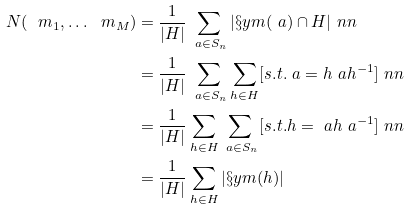Convert formula to latex. <formula><loc_0><loc_0><loc_500><loc_500>N ( \ m _ { 1 } , \dots \ m _ { M } ) & = \frac { 1 } { | H | } \sum _ { \ a \in S _ { n } } | \S y m ( \ a ) \cap H | \ n n \\ & = \frac { 1 } { | H | } \sum _ { \ a \in S _ { n } } \sum _ { h \in H } [ s . t . \ a = h \ a h ^ { - 1 } ] \ n n \\ & = \frac { 1 } { | H | } \sum _ { h \in H } \sum _ { \ a \in S _ { n } } [ s . t . h = \ a h \ a ^ { - 1 } ] \ n n \\ & = \frac { 1 } { | H | } \sum _ { h \in H } | \S y m ( h ) |</formula> 